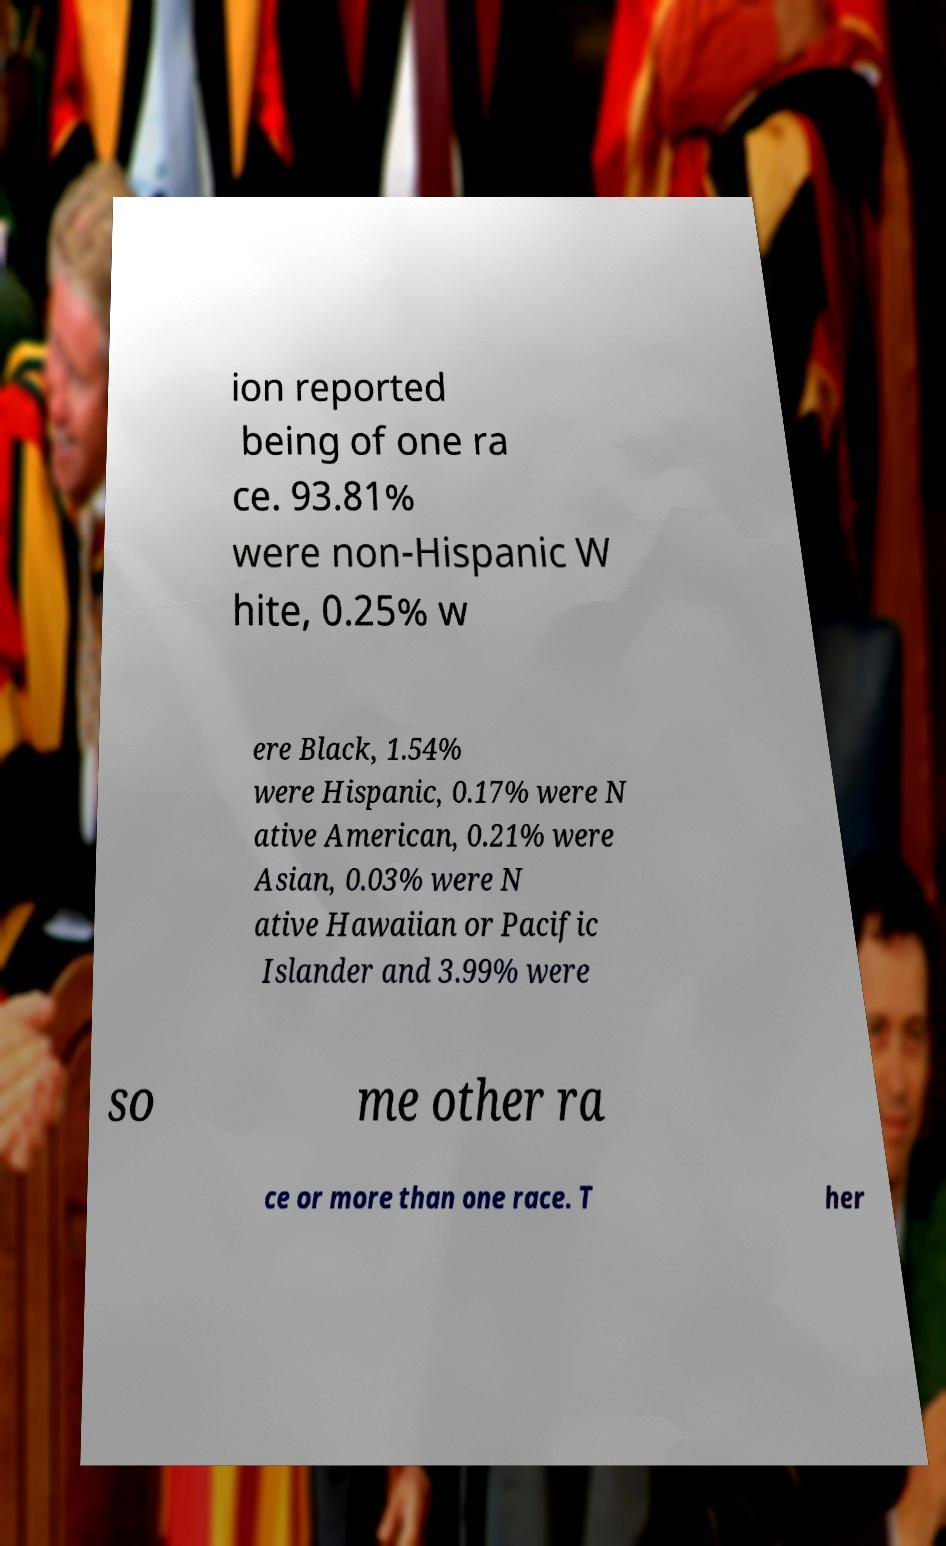Could you extract and type out the text from this image? ion reported being of one ra ce. 93.81% were non-Hispanic W hite, 0.25% w ere Black, 1.54% were Hispanic, 0.17% were N ative American, 0.21% were Asian, 0.03% were N ative Hawaiian or Pacific Islander and 3.99% were so me other ra ce or more than one race. T her 